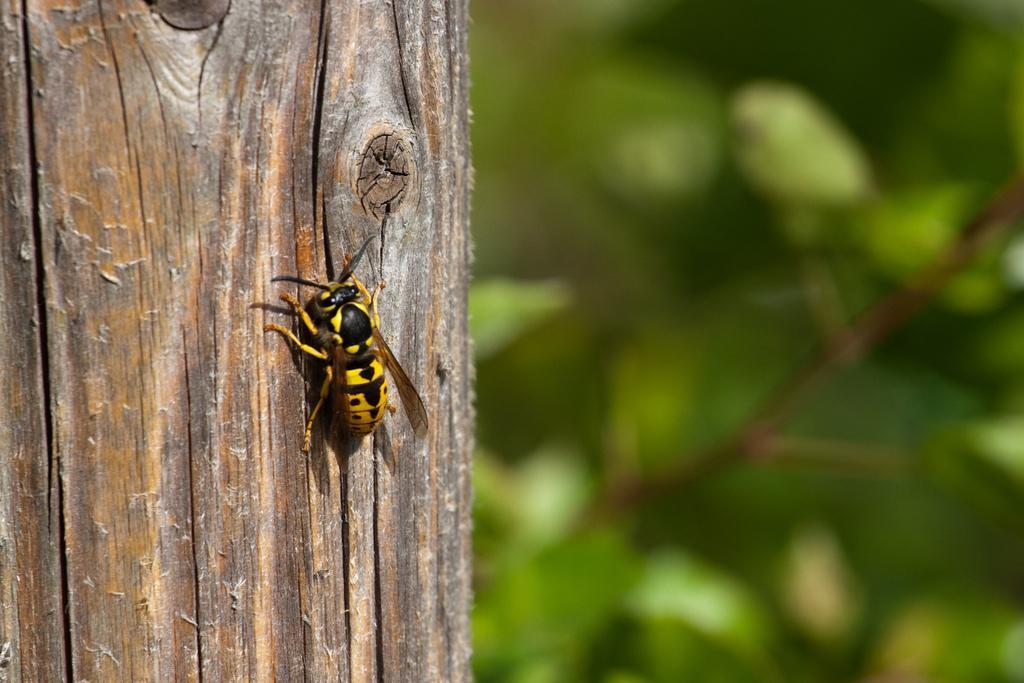Can you describe this image briefly? In this image, I can see an insect on the tree trunk. The background looks green in color, which is blur. 